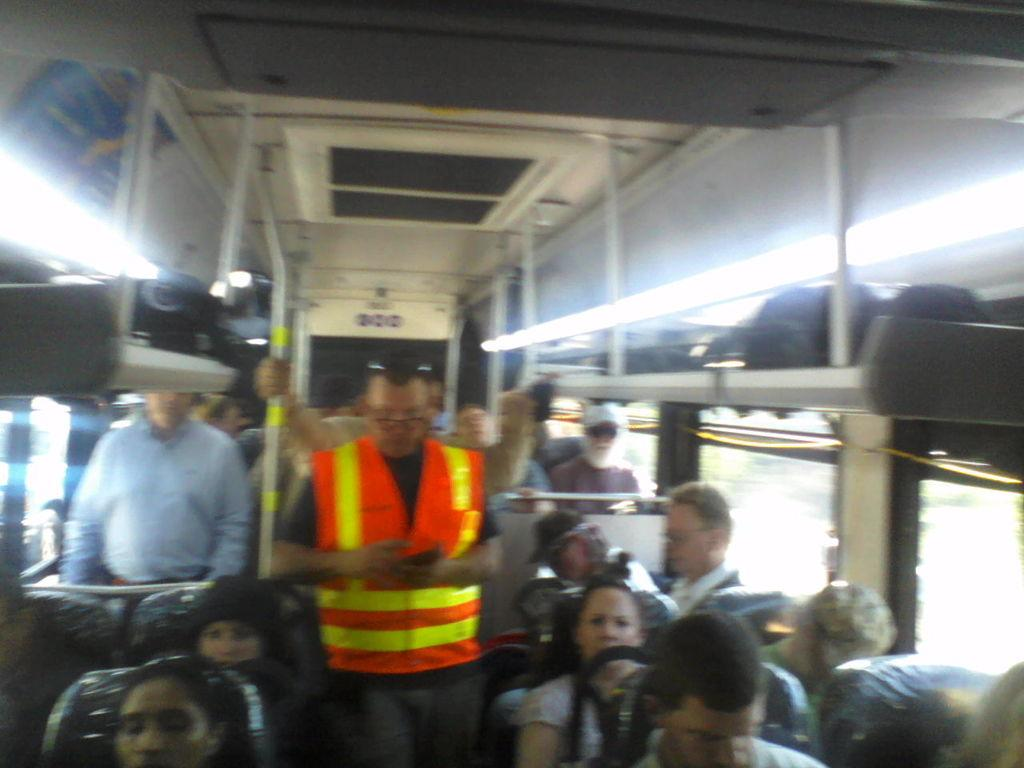What are the people in the image doing? The people in the image are standing and sitting. Where are the people located? The people are in a bus. What are some features of the bus? The bus has metal rods and glass windows. What can be seen on the exterior of the bus? There is a luggage platform in the image, and luggages are placed on it. Can you see a rose on the luggage platform in the image? No, there is no rose present on the luggage platform in the image. Is there a dog sitting next to the people in the bus? No, there is no dog visible in the image; only people are present in the bus. 